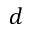<formula> <loc_0><loc_0><loc_500><loc_500>d</formula> 